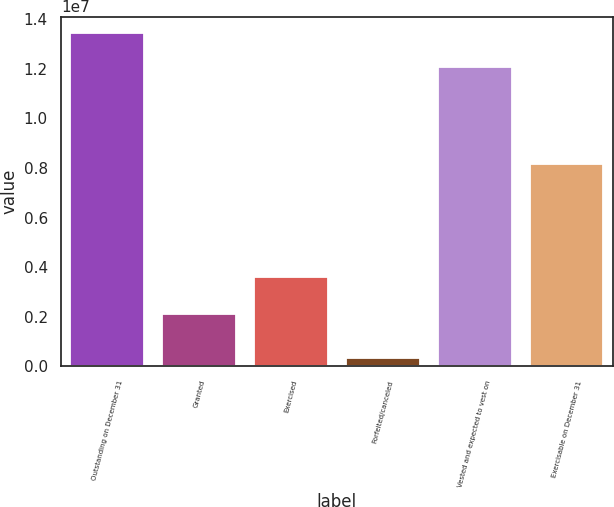Convert chart to OTSL. <chart><loc_0><loc_0><loc_500><loc_500><bar_chart><fcel>Outstanding on December 31<fcel>Granted<fcel>Exercised<fcel>Forfeited/canceled<fcel>Vested and expected to vest on<fcel>Exercisable on December 31<nl><fcel>1.34256e+07<fcel>2.12597e+06<fcel>3.6203e+06<fcel>356540<fcel>1.20586e+07<fcel>8.15338e+06<nl></chart> 